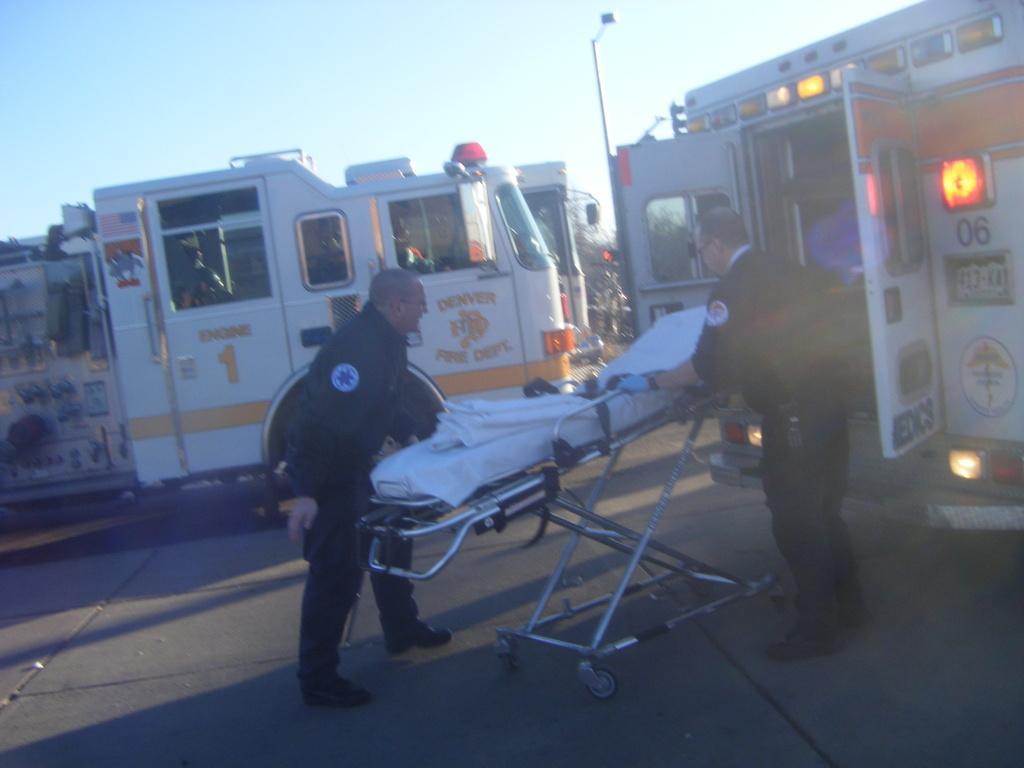Describe this image in one or two sentences. In the background of the image there is a fire extinguisher. There is a bus. To the right side of the image there is an ambulance. There are two persons standing. There is a stretcher. There are light poles. At the bottom of the image there is a road. 